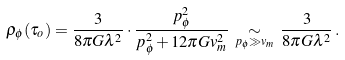Convert formula to latex. <formula><loc_0><loc_0><loc_500><loc_500>\rho _ { \phi } ( \tau _ { o } ) = \frac { 3 } { 8 \pi G \lambda ^ { 2 } } \cdot \frac { p _ { \phi } ^ { 2 } } { p _ { \phi } ^ { 2 } + 1 2 \pi G v _ { m } ^ { 2 } } \, \underset { p _ { \phi } \gg v _ { m } } \sim \, \frac { 3 } { 8 \pi G \lambda ^ { 2 } } \, .</formula> 